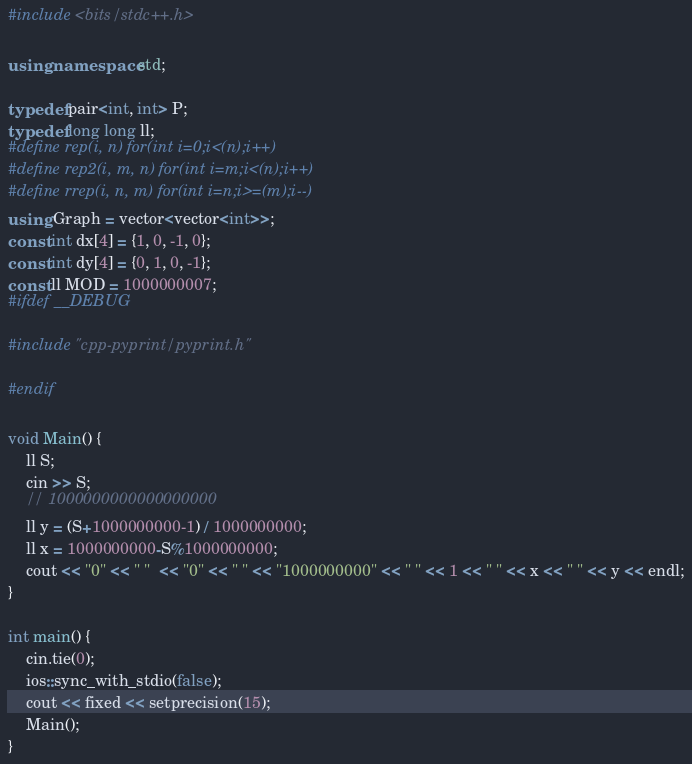<code> <loc_0><loc_0><loc_500><loc_500><_C++_>#include <bits/stdc++.h>

using namespace std;

typedef pair<int, int> P;
typedef long long ll;
#define rep(i, n) for(int i=0;i<(n);i++)
#define rep2(i, m, n) for(int i=m;i<(n);i++)
#define rrep(i, n, m) for(int i=n;i>=(m);i--)
using Graph = vector<vector<int>>;
const int dx[4] = {1, 0, -1, 0};
const int dy[4] = {0, 1, 0, -1};
const ll MOD = 1000000007;
#ifdef __DEBUG

#include "cpp-pyprint/pyprint.h"

#endif

void Main() {
    ll S;
    cin >> S;
    // 1000000000000000000
    ll y = (S+1000000000-1) / 1000000000;
    ll x = 1000000000-S%1000000000;
    cout << "0" << " "  << "0" << " " << "1000000000" << " " << 1 << " " << x << " " << y << endl;
}

int main() {
    cin.tie(0);
    ios::sync_with_stdio(false);
    cout << fixed << setprecision(15);
    Main();
}
</code> 